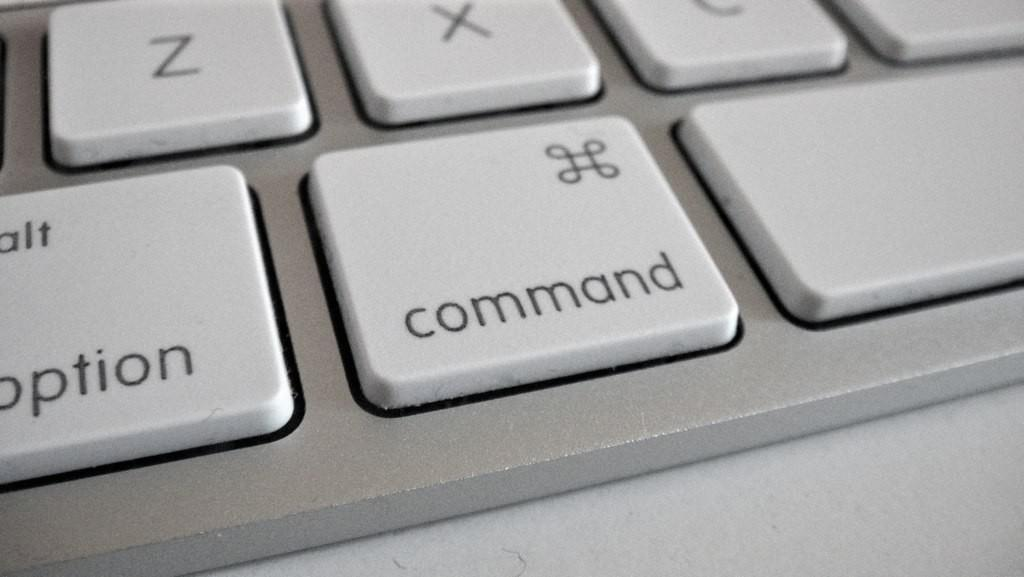<image>
Render a clear and concise summary of the photo. The option and command keys of a white computer keyboard. 